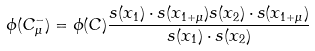<formula> <loc_0><loc_0><loc_500><loc_500>\phi ( C ^ { - } _ { \mu } ) = \phi ( C ) \frac { s ( x _ { 1 } ) \cdot s ( x _ { 1 + \mu } ) s ( x _ { 2 } ) \cdot s ( x _ { 1 + \mu } ) } { s ( x _ { 1 } ) \cdot s ( x _ { 2 } ) } \\</formula> 